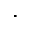Convert formula to latex. <formula><loc_0><loc_0><loc_500><loc_500>\cdot</formula> 